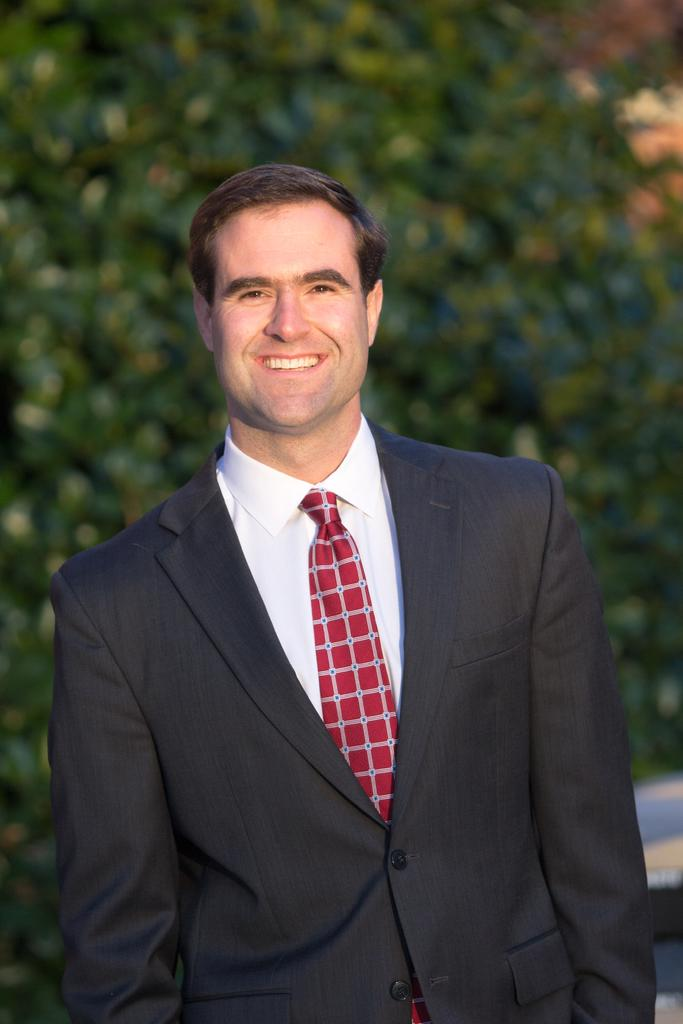Who is the main subject in the image? There is a man in the center of the image. What is the man doing in the image? The man is standing and smiling. What is the man wearing in the image? The man is wearing a suit. What can be seen in the background of the image? There are trees in the background of the image. What type of vase is placed on the man's head in the image? There is no vase present on the man's head in the image. What is the relation between the man and the trees in the background? A: The image does not provide any information about the man's relation to the trees in the background. 